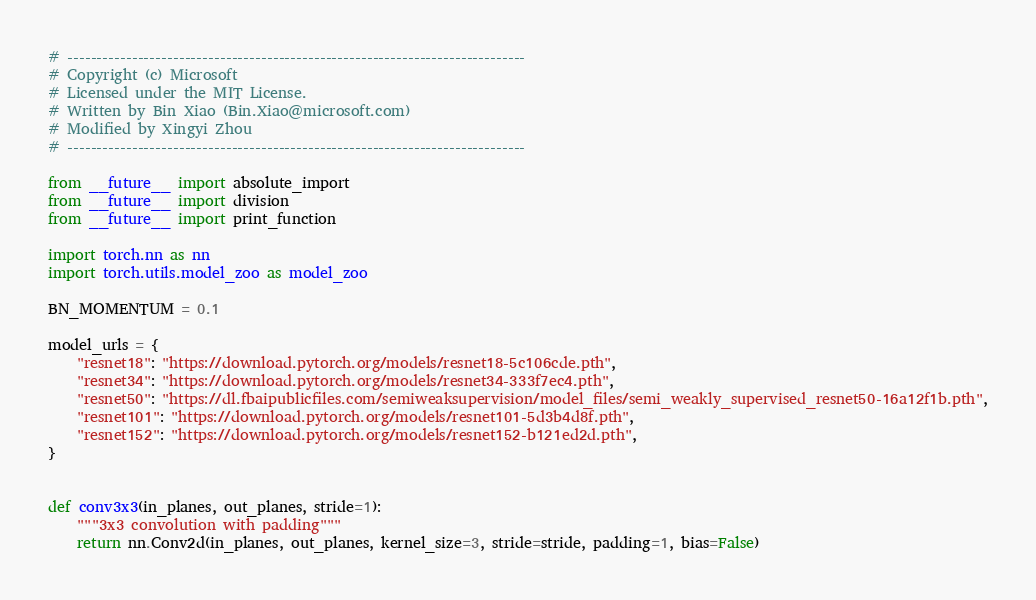<code> <loc_0><loc_0><loc_500><loc_500><_Python_># ------------------------------------------------------------------------------
# Copyright (c) Microsoft
# Licensed under the MIT License.
# Written by Bin Xiao (Bin.Xiao@microsoft.com)
# Modified by Xingyi Zhou
# ------------------------------------------------------------------------------

from __future__ import absolute_import
from __future__ import division
from __future__ import print_function

import torch.nn as nn
import torch.utils.model_zoo as model_zoo

BN_MOMENTUM = 0.1

model_urls = {
    "resnet18": "https://download.pytorch.org/models/resnet18-5c106cde.pth",
    "resnet34": "https://download.pytorch.org/models/resnet34-333f7ec4.pth",
    "resnet50": "https://dl.fbaipublicfiles.com/semiweaksupervision/model_files/semi_weakly_supervised_resnet50-16a12f1b.pth",
    "resnet101": "https://download.pytorch.org/models/resnet101-5d3b4d8f.pth",
    "resnet152": "https://download.pytorch.org/models/resnet152-b121ed2d.pth",
}


def conv3x3(in_planes, out_planes, stride=1):
    """3x3 convolution with padding"""
    return nn.Conv2d(in_planes, out_planes, kernel_size=3, stride=stride, padding=1, bias=False)

</code> 